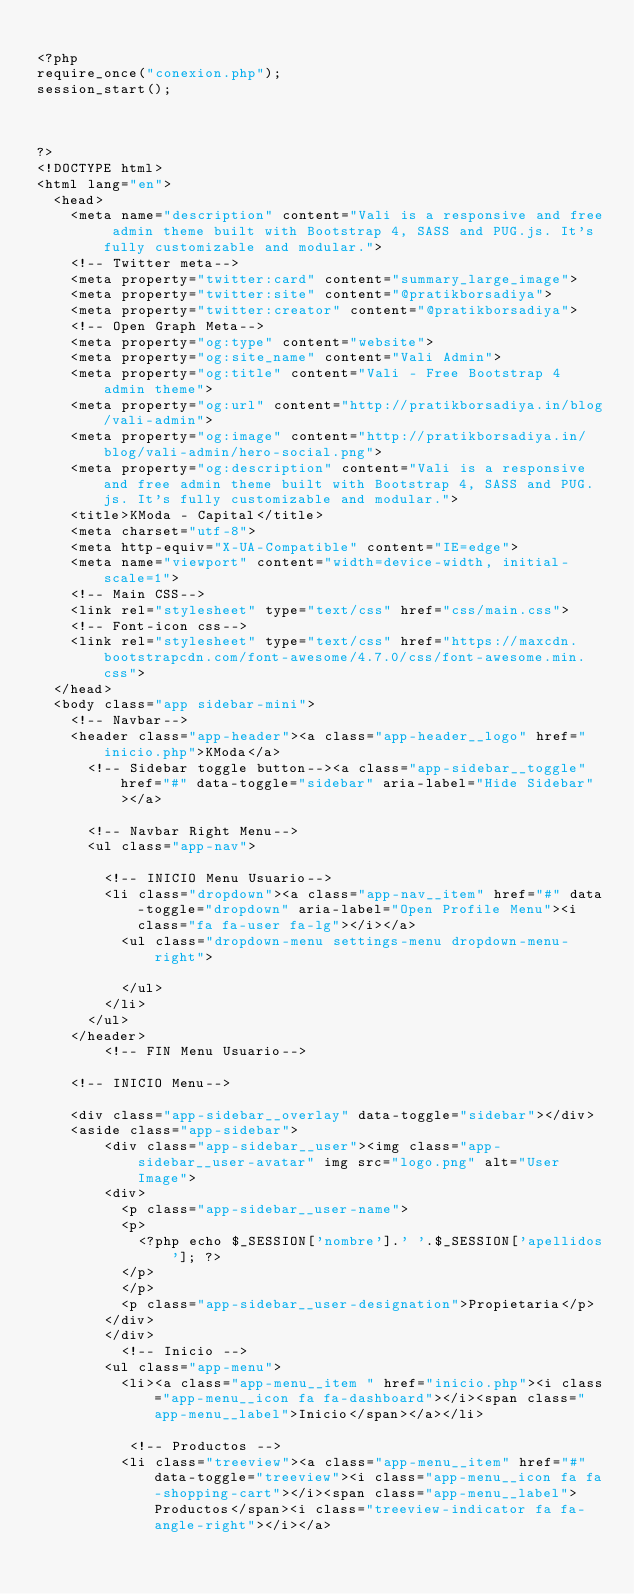<code> <loc_0><loc_0><loc_500><loc_500><_PHP_>
<?php
require_once("conexion.php");
session_start();



?>
<!DOCTYPE html>
<html lang="en">
  <head>
    <meta name="description" content="Vali is a responsive and free admin theme built with Bootstrap 4, SASS and PUG.js. It's fully customizable and modular.">
    <!-- Twitter meta-->
    <meta property="twitter:card" content="summary_large_image">
    <meta property="twitter:site" content="@pratikborsadiya">
    <meta property="twitter:creator" content="@pratikborsadiya">
    <!-- Open Graph Meta-->
    <meta property="og:type" content="website">
    <meta property="og:site_name" content="Vali Admin">
    <meta property="og:title" content="Vali - Free Bootstrap 4 admin theme">
    <meta property="og:url" content="http://pratikborsadiya.in/blog/vali-admin">
    <meta property="og:image" content="http://pratikborsadiya.in/blog/vali-admin/hero-social.png">
    <meta property="og:description" content="Vali is a responsive and free admin theme built with Bootstrap 4, SASS and PUG.js. It's fully customizable and modular.">
    <title>KModa - Capital</title>
    <meta charset="utf-8">
    <meta http-equiv="X-UA-Compatible" content="IE=edge">
    <meta name="viewport" content="width=device-width, initial-scale=1">
    <!-- Main CSS-->
    <link rel="stylesheet" type="text/css" href="css/main.css">
    <!-- Font-icon css-->
    <link rel="stylesheet" type="text/css" href="https://maxcdn.bootstrapcdn.com/font-awesome/4.7.0/css/font-awesome.min.css">
  </head>
  <body class="app sidebar-mini">
    <!-- Navbar-->
    <header class="app-header"><a class="app-header__logo" href="inicio.php">KModa</a>
      <!-- Sidebar toggle button--><a class="app-sidebar__toggle" href="#" data-toggle="sidebar" aria-label="Hide Sidebar"></a>
      
      <!-- Navbar Right Menu-->
      <ul class="app-nav">
     
        <!-- INICIO Menu Usuario-->
        <li class="dropdown"><a class="app-nav__item" href="#" data-toggle="dropdown" aria-label="Open Profile Menu"><i class="fa fa-user fa-lg"></i></a>
          <ul class="dropdown-menu settings-menu dropdown-menu-right">
       
          </ul>
        </li>
      </ul>
    </header>
        <!-- FIN Menu Usuario-->

    <!-- INICIO Menu-->

    <div class="app-sidebar__overlay" data-toggle="sidebar"></div>
    <aside class="app-sidebar">
        <div class="app-sidebar__user"><img class="app-sidebar__user-avatar" img src="logo.png" alt="User Image">
        <div>
          <p class="app-sidebar__user-name">
          <p>
            <?php echo $_SESSION['nombre'].' '.$_SESSION['apellidos']; ?>
          </p>
          </p>
          <p class="app-sidebar__user-designation">Propietaria</p>
        </div>
        </div>
          <!-- Inicio -->
        <ul class="app-menu">
          <li><a class="app-menu__item " href="inicio.php"><i class="app-menu__icon fa fa-dashboard"></i><span class="app-menu__label">Inicio</span></a></li>
  
           <!-- Productos -->
          <li class="treeview"><a class="app-menu__item" href="#" data-toggle="treeview"><i class="app-menu__icon fa fa-shopping-cart"></i><span class="app-menu__label">Productos</span><i class="treeview-indicator fa fa-angle-right"></i></a></code> 